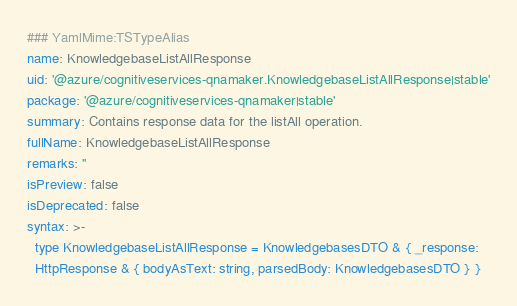Convert code to text. <code><loc_0><loc_0><loc_500><loc_500><_YAML_>### YamlMime:TSTypeAlias
name: KnowledgebaseListAllResponse
uid: '@azure/cognitiveservices-qnamaker.KnowledgebaseListAllResponse|stable'
package: '@azure/cognitiveservices-qnamaker|stable'
summary: Contains response data for the listAll operation.
fullName: KnowledgebaseListAllResponse
remarks: ''
isPreview: false
isDeprecated: false
syntax: >-
  type KnowledgebaseListAllResponse = KnowledgebasesDTO & { _response:
  HttpResponse & { bodyAsText: string, parsedBody: KnowledgebasesDTO } }
</code> 